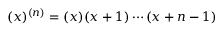Convert formula to latex. <formula><loc_0><loc_0><loc_500><loc_500>( x ) ^ { ( n ) } = ( x ) ( x + 1 ) \cdots ( x + n - 1 )</formula> 